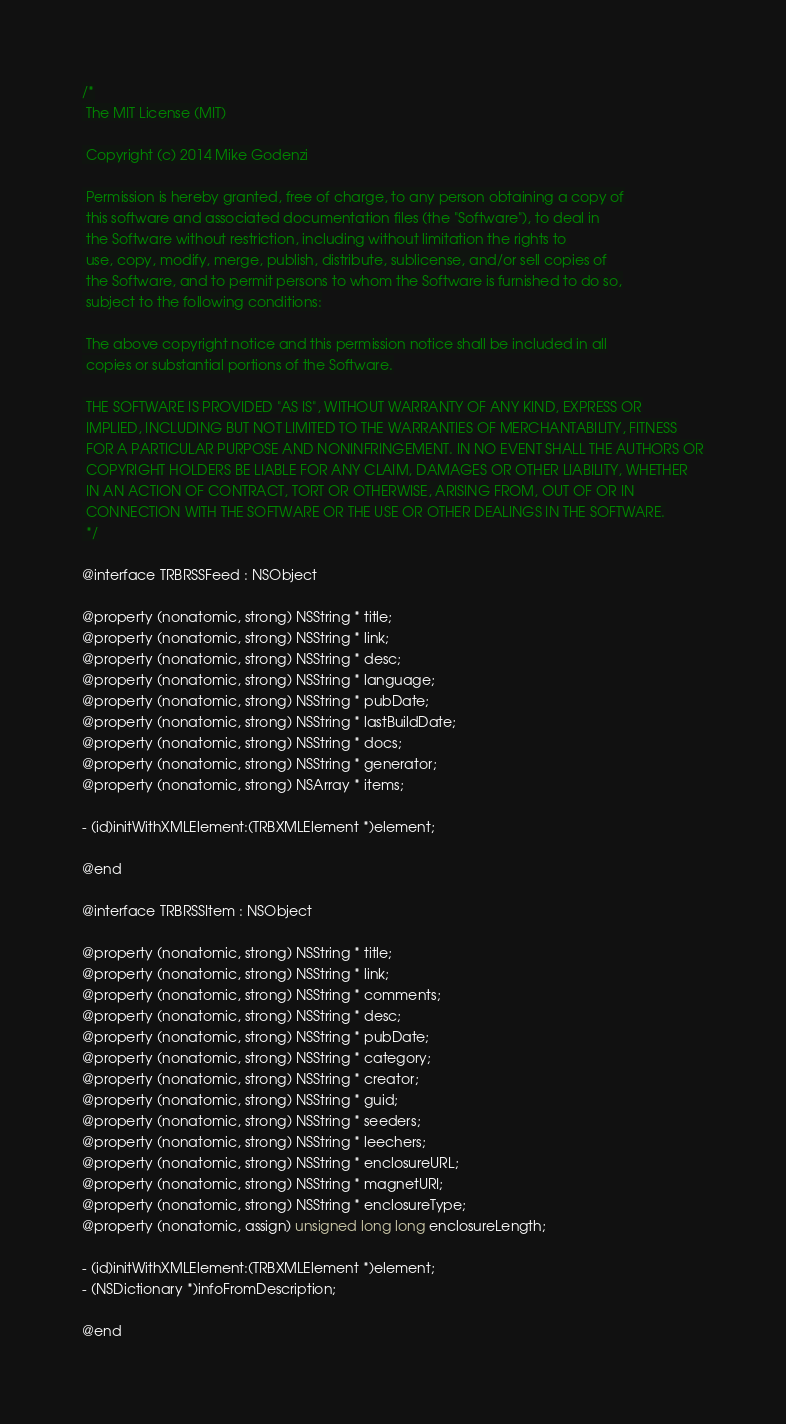Convert code to text. <code><loc_0><loc_0><loc_500><loc_500><_C_>/*
 The MIT License (MIT)

 Copyright (c) 2014 Mike Godenzi

 Permission is hereby granted, free of charge, to any person obtaining a copy of
 this software and associated documentation files (the "Software"), to deal in
 the Software without restriction, including without limitation the rights to
 use, copy, modify, merge, publish, distribute, sublicense, and/or sell copies of
 the Software, and to permit persons to whom the Software is furnished to do so,
 subject to the following conditions:

 The above copyright notice and this permission notice shall be included in all
 copies or substantial portions of the Software.

 THE SOFTWARE IS PROVIDED "AS IS", WITHOUT WARRANTY OF ANY KIND, EXPRESS OR
 IMPLIED, INCLUDING BUT NOT LIMITED TO THE WARRANTIES OF MERCHANTABILITY, FITNESS
 FOR A PARTICULAR PURPOSE AND NONINFRINGEMENT. IN NO EVENT SHALL THE AUTHORS OR
 COPYRIGHT HOLDERS BE LIABLE FOR ANY CLAIM, DAMAGES OR OTHER LIABILITY, WHETHER
 IN AN ACTION OF CONTRACT, TORT OR OTHERWISE, ARISING FROM, OUT OF OR IN
 CONNECTION WITH THE SOFTWARE OR THE USE OR OTHER DEALINGS IN THE SOFTWARE.
 */

@interface TRBRSSFeed : NSObject

@property (nonatomic, strong) NSString * title;
@property (nonatomic, strong) NSString * link;
@property (nonatomic, strong) NSString * desc;
@property (nonatomic, strong) NSString * language;
@property (nonatomic, strong) NSString * pubDate;
@property (nonatomic, strong) NSString * lastBuildDate;
@property (nonatomic, strong) NSString * docs;
@property (nonatomic, strong) NSString * generator;
@property (nonatomic, strong) NSArray * items;

- (id)initWithXMLElement:(TRBXMLElement *)element;

@end

@interface TRBRSSItem : NSObject

@property (nonatomic, strong) NSString * title;
@property (nonatomic, strong) NSString * link;
@property (nonatomic, strong) NSString * comments;
@property (nonatomic, strong) NSString * desc;
@property (nonatomic, strong) NSString * pubDate;
@property (nonatomic, strong) NSString * category;
@property (nonatomic, strong) NSString * creator;
@property (nonatomic, strong) NSString * guid;
@property (nonatomic, strong) NSString * seeders;
@property (nonatomic, strong) NSString * leechers;
@property (nonatomic, strong) NSString * enclosureURL;
@property (nonatomic, strong) NSString * magnetURI;
@property (nonatomic, strong) NSString * enclosureType;
@property (nonatomic, assign) unsigned long long enclosureLength;

- (id)initWithXMLElement:(TRBXMLElement *)element;
- (NSDictionary *)infoFromDescription;

@end
</code> 